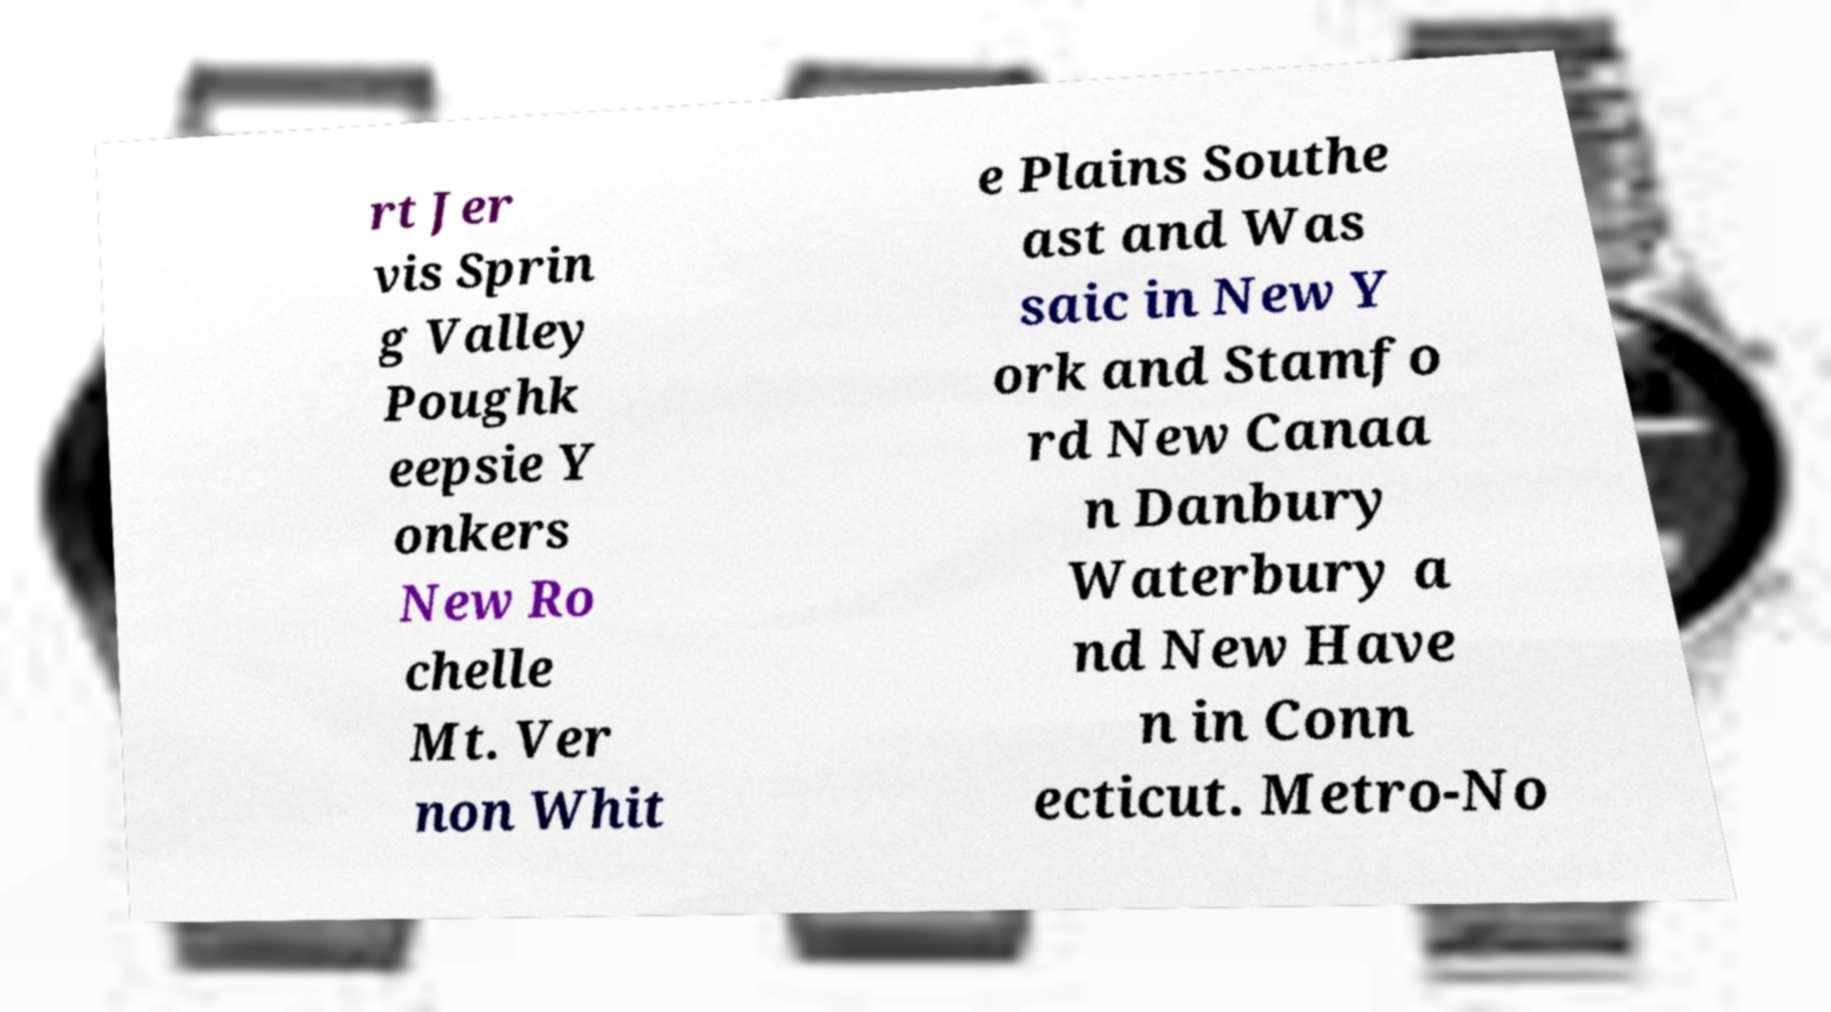Please read and relay the text visible in this image. What does it say? rt Jer vis Sprin g Valley Poughk eepsie Y onkers New Ro chelle Mt. Ver non Whit e Plains Southe ast and Was saic in New Y ork and Stamfo rd New Canaa n Danbury Waterbury a nd New Have n in Conn ecticut. Metro-No 